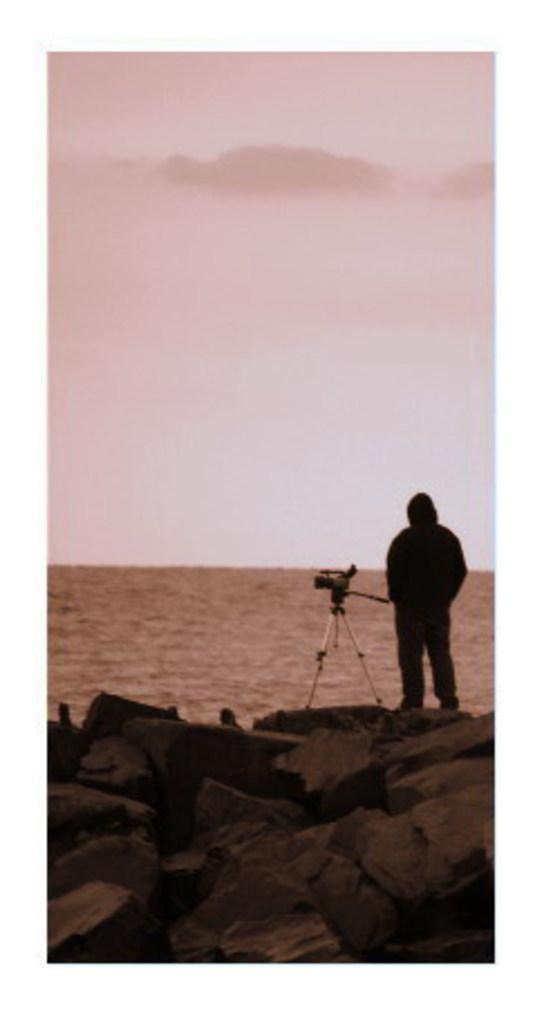In one or two sentences, can you explain what this image depicts? In this image we can see a person and there is a camera placed on the stand. At the bottom there are rocks. In the background there is water and we can see the sky. 